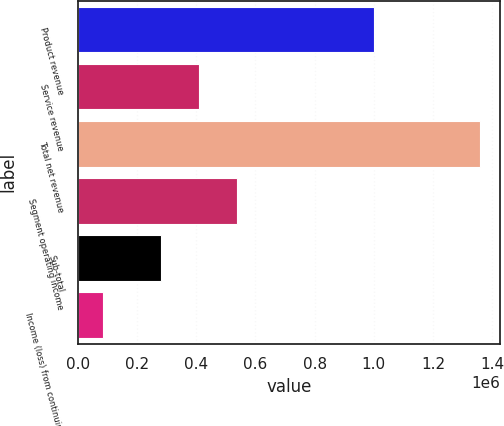Convert chart. <chart><loc_0><loc_0><loc_500><loc_500><bar_chart><fcel>Product revenue<fcel>Service revenue<fcel>Total net revenue<fcel>Segment operating income<fcel>Sub-total<fcel>Income (loss) from continuing<nl><fcel>1.00178e+06<fcel>409753<fcel>1.35835e+06<fcel>537094<fcel>282412<fcel>84939<nl></chart> 